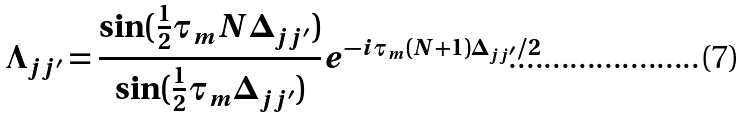<formula> <loc_0><loc_0><loc_500><loc_500>\Lambda _ { j j ^ { \prime } } = \frac { \sin ( \frac { 1 } { 2 } \tau _ { m } N \Delta _ { j j ^ { \prime } } ) } { \sin ( \frac { 1 } { 2 } \tau _ { m } \Delta _ { j j ^ { \prime } } ) } e ^ { - i \tau _ { m } ( N + 1 ) \Delta _ { j j ^ { \prime } } / 2 }</formula> 